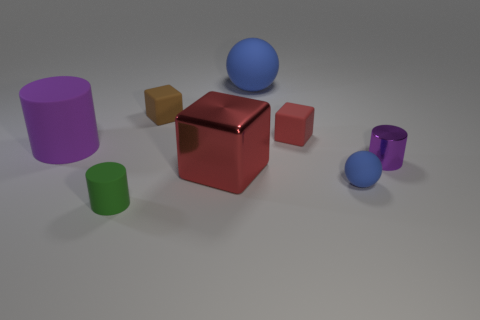Add 1 gray rubber blocks. How many objects exist? 9 Subtract all spheres. How many objects are left? 6 Add 7 big purple matte balls. How many big purple matte balls exist? 7 Subtract 0 blue cylinders. How many objects are left? 8 Subtract all rubber blocks. Subtract all small metal things. How many objects are left? 5 Add 5 small green rubber things. How many small green rubber things are left? 6 